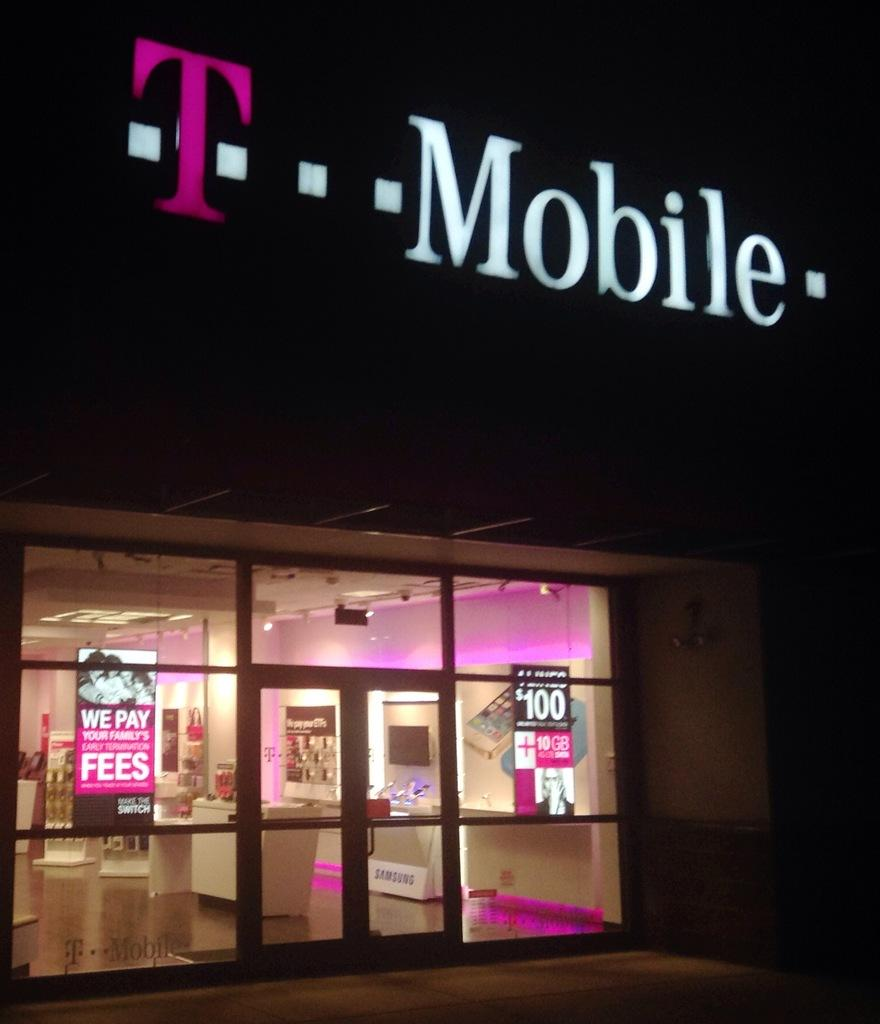What type of establishment is depicted in the image? There is a store in the image. What products are being sold in the store? Mobile phones are arranged in racks in the store. Are there any promotional materials visible in the image? Yes, there are advertisement boards in the image. How can customers identify the store's name? There is a name board in the image. What type of dinner is being served in the store? There is no dinner being served in the store; the image features a store selling mobile phones. 